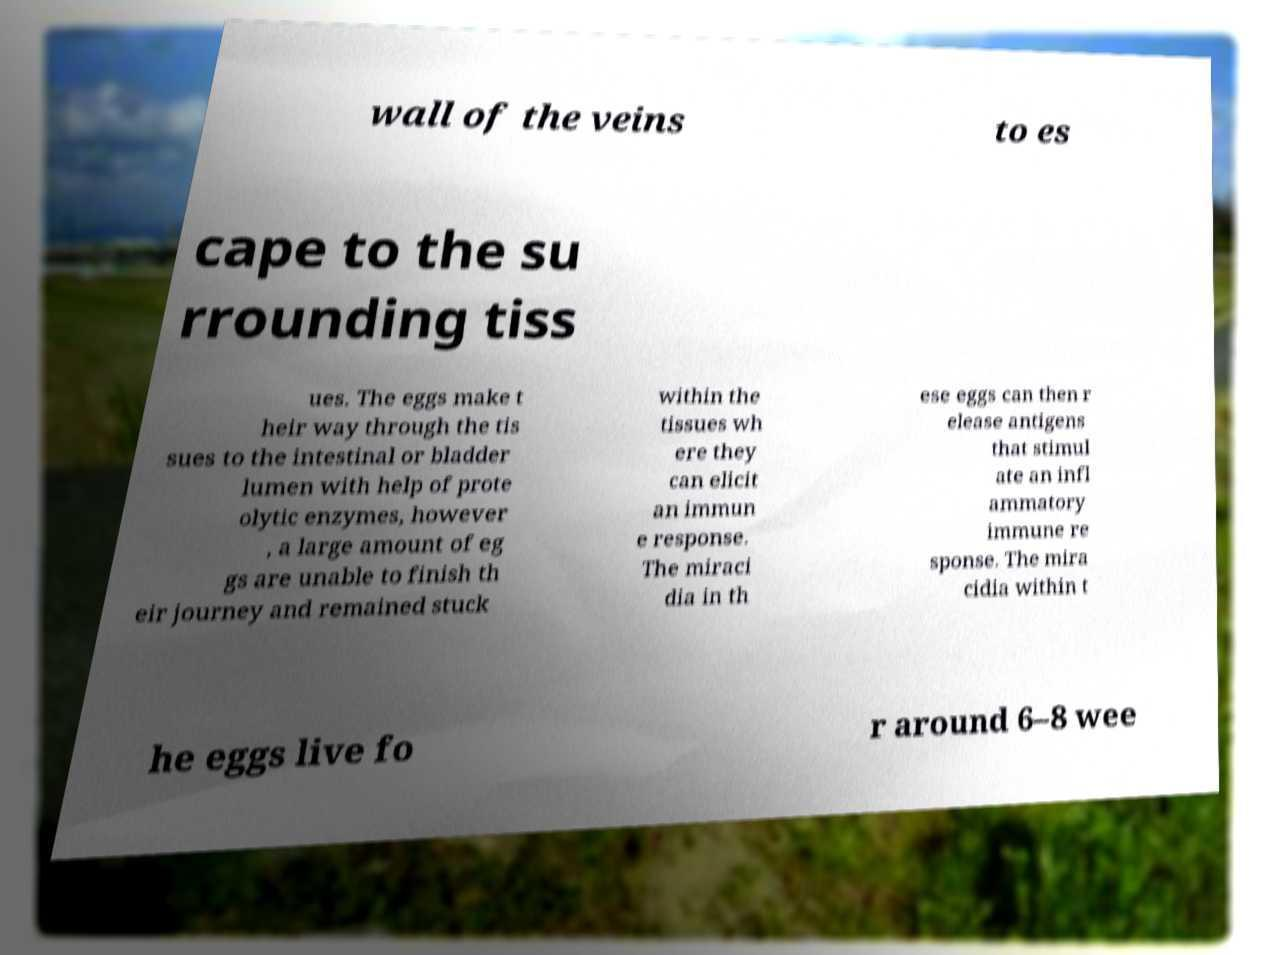Could you assist in decoding the text presented in this image and type it out clearly? wall of the veins to es cape to the su rrounding tiss ues. The eggs make t heir way through the tis sues to the intestinal or bladder lumen with help of prote olytic enzymes, however , a large amount of eg gs are unable to finish th eir journey and remained stuck within the tissues wh ere they can elicit an immun e response. The miraci dia in th ese eggs can then r elease antigens that stimul ate an infl ammatory immune re sponse. The mira cidia within t he eggs live fo r around 6–8 wee 